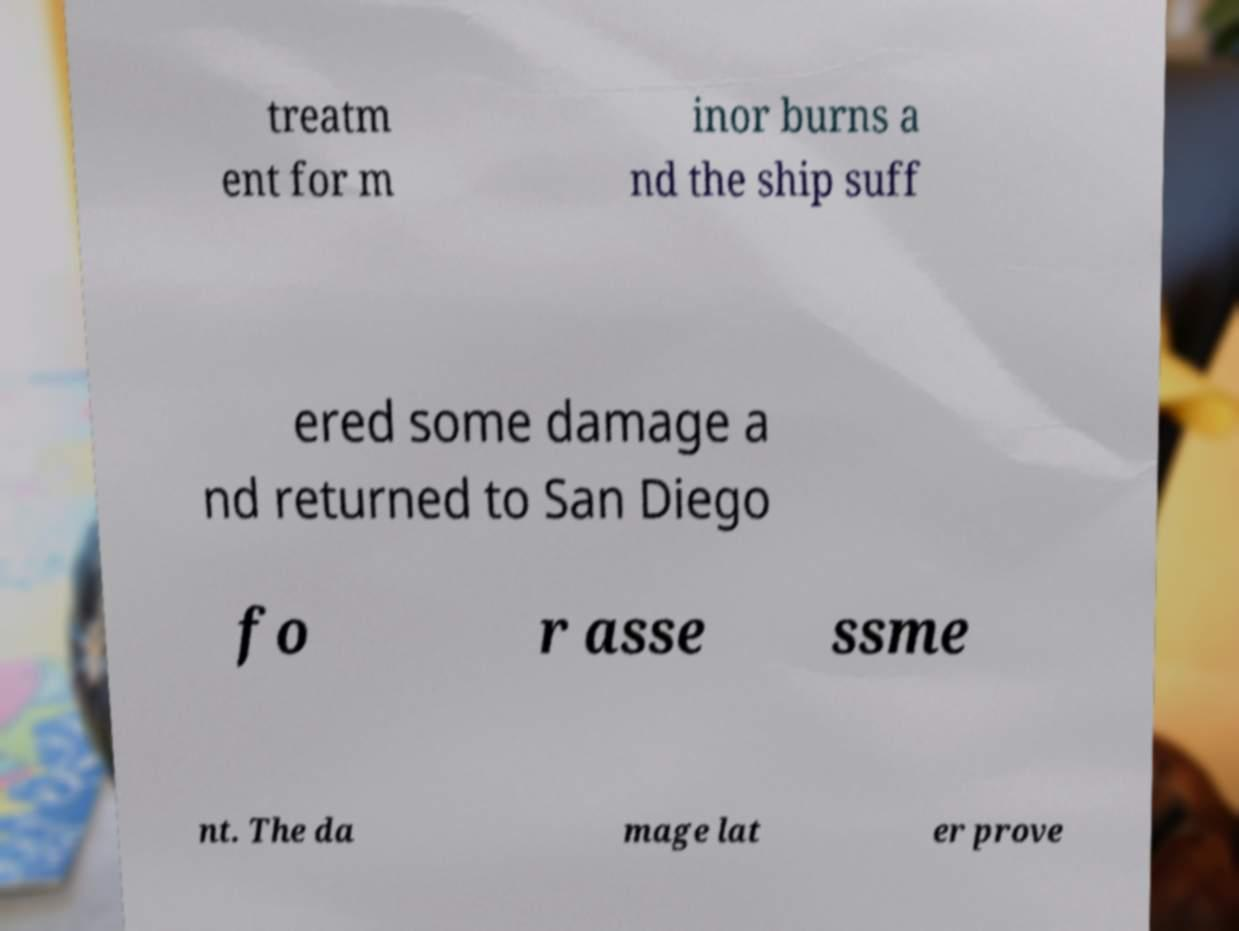Please read and relay the text visible in this image. What does it say? treatm ent for m inor burns a nd the ship suff ered some damage a nd returned to San Diego fo r asse ssme nt. The da mage lat er prove 